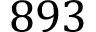Convert formula to latex. <formula><loc_0><loc_0><loc_500><loc_500>8 9 3</formula> 